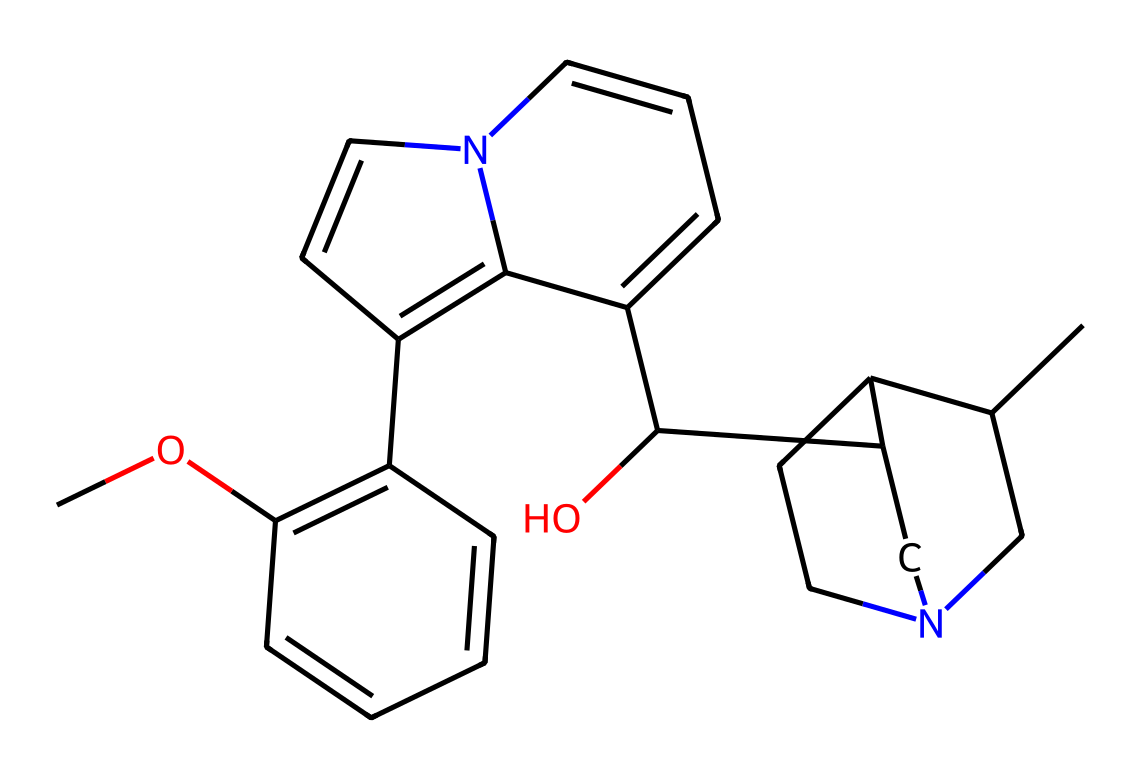What is the molecular formula of quinine? To determine the molecular formula, count the number of each type of atom in the structure represented by the SMILES. From the structure, there are 20 carbon atoms, 24 hydrogen atoms, 1 nitrogen atom, and 1 oxygen atom, leading to the formula C20H24N2O.
Answer: C20H24N2O How many rings are present in the quinine structure? Examine the structure for circular arrangements of atoms, focusing on closed loops. Quinine contains 4 rings visible when analyzing the molecule, including the indole and piperidine moieties.
Answer: 4 What functional groups are present in quinine? Identify prominent features in the chemical structure that denote functional groups. Quinine contains alcohol (the hydroxyl group), ether (the alkoxy part), and amine (the nitrogen atom in the piperidine ring) functional groups.
Answer: alcohol, ether, amine What causes quinine's characteristic bitterness? The presence of a nitrogen atom is a key indicator in alkaloids, which often contribute to a bitter taste. Analyzing the structure reveals that the nitrogen in the piperidine ring is responsible for bitterness.
Answer: nitrogen Is quinine a base or an acid? To determine the nature of quinine, evaluate the functional groups present. The presence of a nitrogen atom which can accept a proton indicates that quinine has basic properties, primarily due to its amine group.
Answer: base 